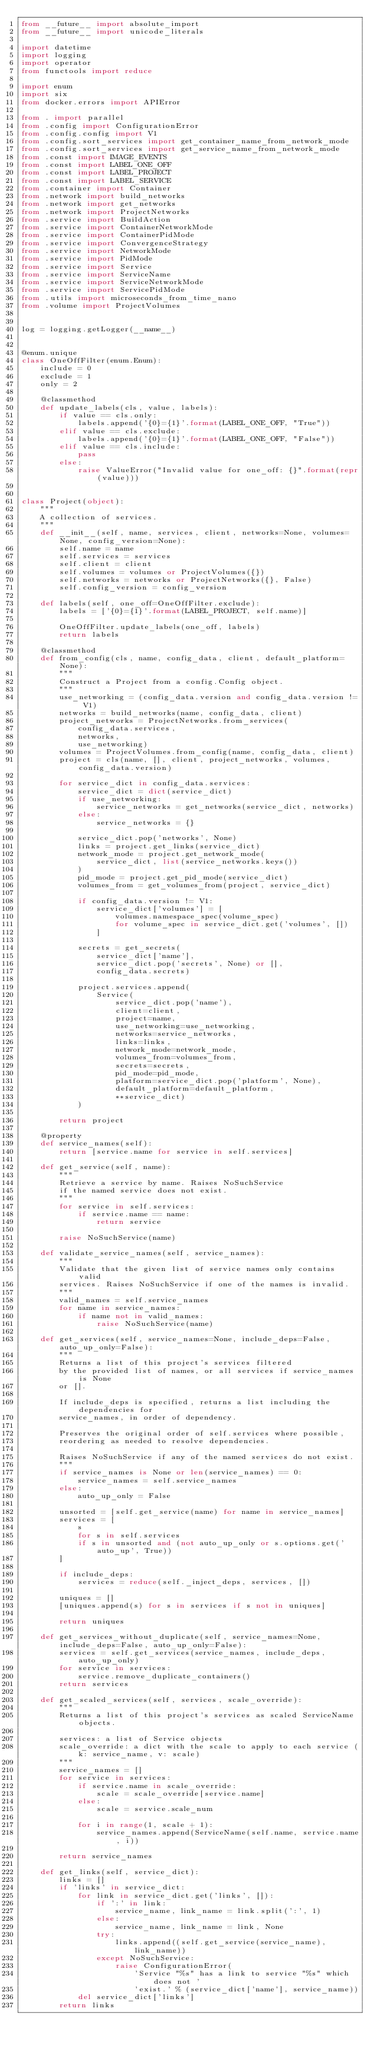Convert code to text. <code><loc_0><loc_0><loc_500><loc_500><_Python_>from __future__ import absolute_import
from __future__ import unicode_literals

import datetime
import logging
import operator
from functools import reduce

import enum
import six
from docker.errors import APIError

from . import parallel
from .config import ConfigurationError
from .config.config import V1
from .config.sort_services import get_container_name_from_network_mode
from .config.sort_services import get_service_name_from_network_mode
from .const import IMAGE_EVENTS
from .const import LABEL_ONE_OFF
from .const import LABEL_PROJECT
from .const import LABEL_SERVICE
from .container import Container
from .network import build_networks
from .network import get_networks
from .network import ProjectNetworks
from .service import BuildAction
from .service import ContainerNetworkMode
from .service import ContainerPidMode
from .service import ConvergenceStrategy
from .service import NetworkMode
from .service import PidMode
from .service import Service
from .service import ServiceName
from .service import ServiceNetworkMode
from .service import ServicePidMode
from .utils import microseconds_from_time_nano
from .volume import ProjectVolumes


log = logging.getLogger(__name__)


@enum.unique
class OneOffFilter(enum.Enum):
    include = 0
    exclude = 1
    only = 2

    @classmethod
    def update_labels(cls, value, labels):
        if value == cls.only:
            labels.append('{0}={1}'.format(LABEL_ONE_OFF, "True"))
        elif value == cls.exclude:
            labels.append('{0}={1}'.format(LABEL_ONE_OFF, "False"))
        elif value == cls.include:
            pass
        else:
            raise ValueError("Invalid value for one_off: {}".format(repr(value)))


class Project(object):
    """
    A collection of services.
    """
    def __init__(self, name, services, client, networks=None, volumes=None, config_version=None):
        self.name = name
        self.services = services
        self.client = client
        self.volumes = volumes or ProjectVolumes({})
        self.networks = networks or ProjectNetworks({}, False)
        self.config_version = config_version

    def labels(self, one_off=OneOffFilter.exclude):
        labels = ['{0}={1}'.format(LABEL_PROJECT, self.name)]

        OneOffFilter.update_labels(one_off, labels)
        return labels

    @classmethod
    def from_config(cls, name, config_data, client, default_platform=None):
        """
        Construct a Project from a config.Config object.
        """
        use_networking = (config_data.version and config_data.version != V1)
        networks = build_networks(name, config_data, client)
        project_networks = ProjectNetworks.from_services(
            config_data.services,
            networks,
            use_networking)
        volumes = ProjectVolumes.from_config(name, config_data, client)
        project = cls(name, [], client, project_networks, volumes, config_data.version)

        for service_dict in config_data.services:
            service_dict = dict(service_dict)
            if use_networking:
                service_networks = get_networks(service_dict, networks)
            else:
                service_networks = {}

            service_dict.pop('networks', None)
            links = project.get_links(service_dict)
            network_mode = project.get_network_mode(
                service_dict, list(service_networks.keys())
            )
            pid_mode = project.get_pid_mode(service_dict)
            volumes_from = get_volumes_from(project, service_dict)

            if config_data.version != V1:
                service_dict['volumes'] = [
                    volumes.namespace_spec(volume_spec)
                    for volume_spec in service_dict.get('volumes', [])
                ]

            secrets = get_secrets(
                service_dict['name'],
                service_dict.pop('secrets', None) or [],
                config_data.secrets)

            project.services.append(
                Service(
                    service_dict.pop('name'),
                    client=client,
                    project=name,
                    use_networking=use_networking,
                    networks=service_networks,
                    links=links,
                    network_mode=network_mode,
                    volumes_from=volumes_from,
                    secrets=secrets,
                    pid_mode=pid_mode,
                    platform=service_dict.pop('platform', None),
                    default_platform=default_platform,
                    **service_dict)
            )

        return project

    @property
    def service_names(self):
        return [service.name for service in self.services]

    def get_service(self, name):
        """
        Retrieve a service by name. Raises NoSuchService
        if the named service does not exist.
        """
        for service in self.services:
            if service.name == name:
                return service

        raise NoSuchService(name)

    def validate_service_names(self, service_names):
        """
        Validate that the given list of service names only contains valid
        services. Raises NoSuchService if one of the names is invalid.
        """
        valid_names = self.service_names
        for name in service_names:
            if name not in valid_names:
                raise NoSuchService(name)

    def get_services(self, service_names=None, include_deps=False, auto_up_only=False):
        """
        Returns a list of this project's services filtered
        by the provided list of names, or all services if service_names is None
        or [].

        If include_deps is specified, returns a list including the dependencies for
        service_names, in order of dependency.

        Preserves the original order of self.services where possible,
        reordering as needed to resolve dependencies.

        Raises NoSuchService if any of the named services do not exist.
        """
        if service_names is None or len(service_names) == 0:
            service_names = self.service_names
        else:
            auto_up_only = False

        unsorted = [self.get_service(name) for name in service_names]
        services = [
            s
            for s in self.services
            if s in unsorted and (not auto_up_only or s.options.get('auto_up', True))
        ]

        if include_deps:
            services = reduce(self._inject_deps, services, [])

        uniques = []
        [uniques.append(s) for s in services if s not in uniques]

        return uniques

    def get_services_without_duplicate(self, service_names=None, include_deps=False, auto_up_only=False):
        services = self.get_services(service_names, include_deps, auto_up_only)
        for service in services:
            service.remove_duplicate_containers()
        return services

    def get_scaled_services(self, services, scale_override):
        """
        Returns a list of this project's services as scaled ServiceName objects.

        services: a list of Service objects
        scale_override: a dict with the scale to apply to each service (k: service_name, v: scale)
        """
        service_names = []
        for service in services:
            if service.name in scale_override:
                scale = scale_override[service.name]
            else:
                scale = service.scale_num

            for i in range(1, scale + 1):
                service_names.append(ServiceName(self.name, service.name, i))

        return service_names

    def get_links(self, service_dict):
        links = []
        if 'links' in service_dict:
            for link in service_dict.get('links', []):
                if ':' in link:
                    service_name, link_name = link.split(':', 1)
                else:
                    service_name, link_name = link, None
                try:
                    links.append((self.get_service(service_name), link_name))
                except NoSuchService:
                    raise ConfigurationError(
                        'Service "%s" has a link to service "%s" which does not '
                        'exist.' % (service_dict['name'], service_name))
            del service_dict['links']
        return links
</code> 